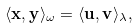Convert formula to latex. <formula><loc_0><loc_0><loc_500><loc_500>\langle \mathbf x , \mathbf y \rangle _ { \omega } = \langle \mathbf u , \mathbf v \rangle _ { \lambda } ,</formula> 